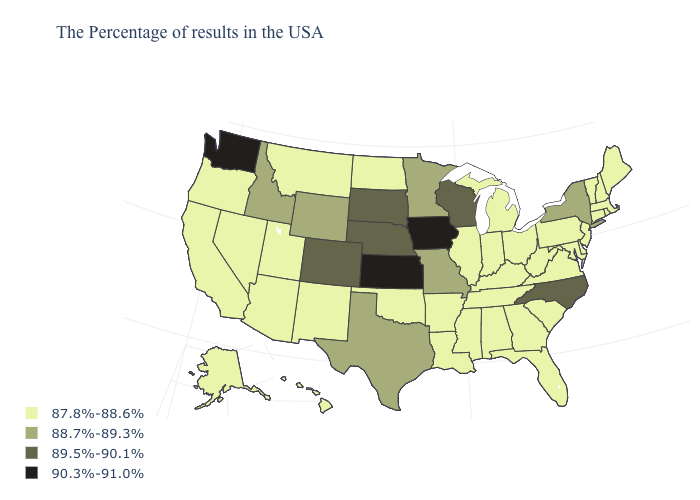What is the lowest value in states that border West Virginia?
Answer briefly. 87.8%-88.6%. Name the states that have a value in the range 88.7%-89.3%?
Concise answer only. New York, Missouri, Minnesota, Texas, Wyoming, Idaho. What is the lowest value in states that border Arkansas?
Write a very short answer. 87.8%-88.6%. Which states have the lowest value in the MidWest?
Quick response, please. Ohio, Michigan, Indiana, Illinois, North Dakota. Which states hav the highest value in the MidWest?
Quick response, please. Iowa, Kansas. Among the states that border Virginia , does Maryland have the highest value?
Short answer required. No. Does South Dakota have a lower value than Tennessee?
Write a very short answer. No. Name the states that have a value in the range 89.5%-90.1%?
Concise answer only. North Carolina, Wisconsin, Nebraska, South Dakota, Colorado. What is the value of Louisiana?
Keep it brief. 87.8%-88.6%. What is the value of Kentucky?
Write a very short answer. 87.8%-88.6%. What is the value of Delaware?
Give a very brief answer. 87.8%-88.6%. Name the states that have a value in the range 89.5%-90.1%?
Answer briefly. North Carolina, Wisconsin, Nebraska, South Dakota, Colorado. Does North Carolina have the highest value in the South?
Write a very short answer. Yes. Among the states that border Illinois , which have the lowest value?
Short answer required. Kentucky, Indiana. Does New Mexico have the highest value in the USA?
Concise answer only. No. 